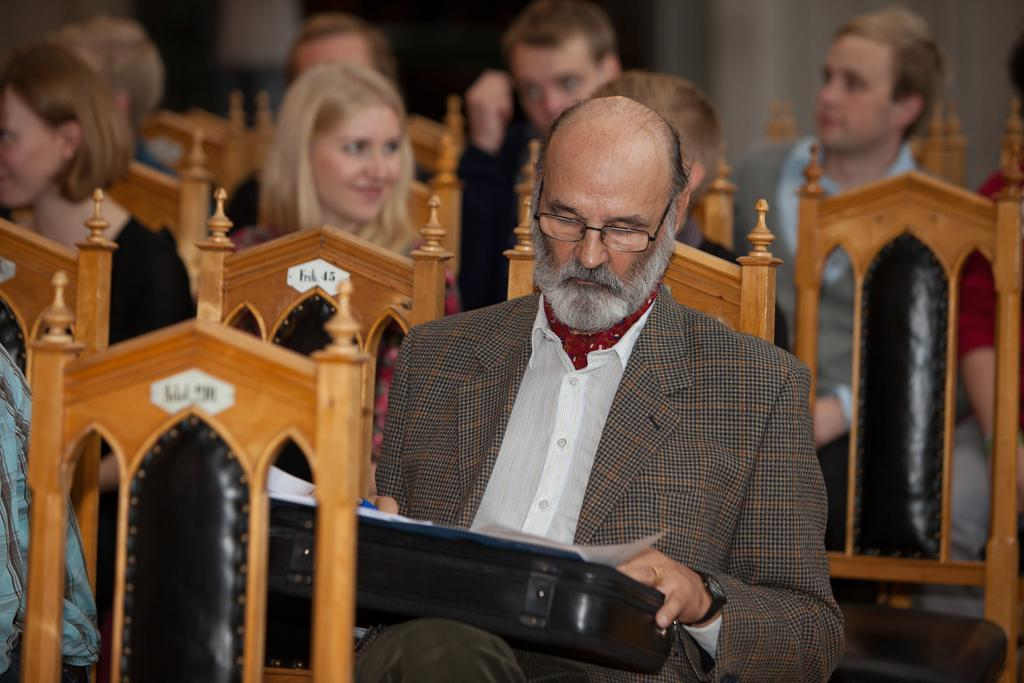How many people are in the image? There are people in the image, but the exact number is not specified. What are the people doing in the image? The people are seated on chairs in the image. Can you describe the person who is holding a briefcase? One person is holding a briefcase, and this person is highlighted in the image. What type of poison is being administered to the geese in the image? There are no geese or poison present in the image. Can you describe the kiss between the two people in the image? There are no people kissing in the image; the people are seated on chairs. 